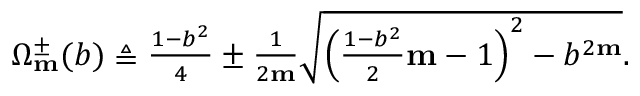Convert formula to latex. <formula><loc_0><loc_0><loc_500><loc_500>\begin{array} { r } { \Omega _ { m } ^ { \pm } ( b ) \triangle q \frac { 1 - b ^ { 2 } } { 4 } \pm \frac { 1 } { 2 m } \sqrt { \left ( \frac { 1 - b ^ { 2 } } { 2 } m - 1 \right ) ^ { 2 } - b ^ { 2 m } } . } \end{array}</formula> 